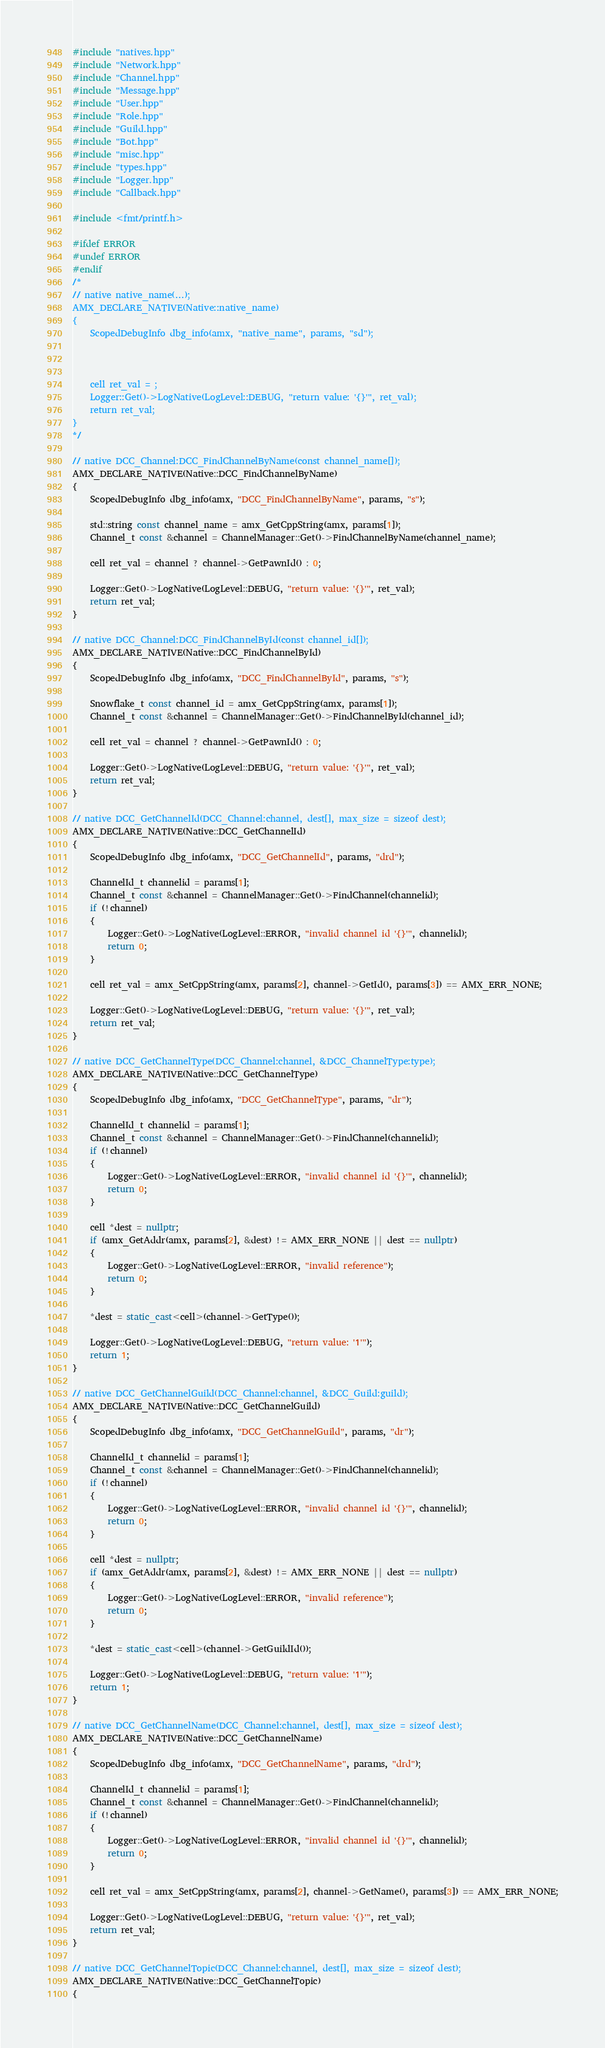<code> <loc_0><loc_0><loc_500><loc_500><_C++_>#include "natives.hpp"
#include "Network.hpp"
#include "Channel.hpp"
#include "Message.hpp"
#include "User.hpp"
#include "Role.hpp"
#include "Guild.hpp"
#include "Bot.hpp"
#include "misc.hpp"
#include "types.hpp"
#include "Logger.hpp"
#include "Callback.hpp"

#include <fmt/printf.h>

#ifdef ERROR
#undef ERROR
#endif
/*
// native native_name(...);
AMX_DECLARE_NATIVE(Native::native_name)
{
	ScopedDebugInfo dbg_info(amx, "native_name", params, "sd");



	cell ret_val = ;
	Logger::Get()->LogNative(LogLevel::DEBUG, "return value: '{}'", ret_val);
	return ret_val;
}
*/

// native DCC_Channel:DCC_FindChannelByName(const channel_name[]);
AMX_DECLARE_NATIVE(Native::DCC_FindChannelByName)
{
	ScopedDebugInfo dbg_info(amx, "DCC_FindChannelByName", params, "s");

	std::string const channel_name = amx_GetCppString(amx, params[1]);
	Channel_t const &channel = ChannelManager::Get()->FindChannelByName(channel_name);

	cell ret_val = channel ? channel->GetPawnId() : 0;

	Logger::Get()->LogNative(LogLevel::DEBUG, "return value: '{}'", ret_val);
	return ret_val;
}

// native DCC_Channel:DCC_FindChannelById(const channel_id[]);
AMX_DECLARE_NATIVE(Native::DCC_FindChannelById)
{
	ScopedDebugInfo dbg_info(amx, "DCC_FindChannelById", params, "s");

	Snowflake_t const channel_id = amx_GetCppString(amx, params[1]);
	Channel_t const &channel = ChannelManager::Get()->FindChannelById(channel_id);

	cell ret_val = channel ? channel->GetPawnId() : 0;

	Logger::Get()->LogNative(LogLevel::DEBUG, "return value: '{}'", ret_val);
	return ret_val;
}

// native DCC_GetChannelId(DCC_Channel:channel, dest[], max_size = sizeof dest);
AMX_DECLARE_NATIVE(Native::DCC_GetChannelId)
{
	ScopedDebugInfo dbg_info(amx, "DCC_GetChannelId", params, "drd");

	ChannelId_t channelid = params[1];
	Channel_t const &channel = ChannelManager::Get()->FindChannel(channelid);
	if (!channel)
	{
		Logger::Get()->LogNative(LogLevel::ERROR, "invalid channel id '{}'", channelid);
		return 0;
	}

	cell ret_val = amx_SetCppString(amx, params[2], channel->GetId(), params[3]) == AMX_ERR_NONE;

	Logger::Get()->LogNative(LogLevel::DEBUG, "return value: '{}'", ret_val);
	return ret_val;
}

// native DCC_GetChannelType(DCC_Channel:channel, &DCC_ChannelType:type);
AMX_DECLARE_NATIVE(Native::DCC_GetChannelType)
{
	ScopedDebugInfo dbg_info(amx, "DCC_GetChannelType", params, "dr");

	ChannelId_t channelid = params[1];
	Channel_t const &channel = ChannelManager::Get()->FindChannel(channelid);
	if (!channel)
	{
		Logger::Get()->LogNative(LogLevel::ERROR, "invalid channel id '{}'", channelid);
		return 0;
	}

	cell *dest = nullptr;
	if (amx_GetAddr(amx, params[2], &dest) != AMX_ERR_NONE || dest == nullptr)
	{
		Logger::Get()->LogNative(LogLevel::ERROR, "invalid reference");
		return 0;
	}

	*dest = static_cast<cell>(channel->GetType());

	Logger::Get()->LogNative(LogLevel::DEBUG, "return value: '1'");
	return 1;
}

// native DCC_GetChannelGuild(DCC_Channel:channel, &DCC_Guild:guild);
AMX_DECLARE_NATIVE(Native::DCC_GetChannelGuild)
{
	ScopedDebugInfo dbg_info(amx, "DCC_GetChannelGuild", params, "dr");

	ChannelId_t channelid = params[1];
	Channel_t const &channel = ChannelManager::Get()->FindChannel(channelid);
	if (!channel)
	{
		Logger::Get()->LogNative(LogLevel::ERROR, "invalid channel id '{}'", channelid);
		return 0;
	}

	cell *dest = nullptr;
	if (amx_GetAddr(amx, params[2], &dest) != AMX_ERR_NONE || dest == nullptr)
	{
		Logger::Get()->LogNative(LogLevel::ERROR, "invalid reference");
		return 0;
	}

	*dest = static_cast<cell>(channel->GetGuildId());

	Logger::Get()->LogNative(LogLevel::DEBUG, "return value: '1'");
	return 1;
}

// native DCC_GetChannelName(DCC_Channel:channel, dest[], max_size = sizeof dest);
AMX_DECLARE_NATIVE(Native::DCC_GetChannelName)
{
	ScopedDebugInfo dbg_info(amx, "DCC_GetChannelName", params, "drd");

	ChannelId_t channelid = params[1];
	Channel_t const &channel = ChannelManager::Get()->FindChannel(channelid);
	if (!channel)
	{
		Logger::Get()->LogNative(LogLevel::ERROR, "invalid channel id '{}'", channelid);
		return 0;
	}

	cell ret_val = amx_SetCppString(amx, params[2], channel->GetName(), params[3]) == AMX_ERR_NONE;

	Logger::Get()->LogNative(LogLevel::DEBUG, "return value: '{}'", ret_val);
	return ret_val;
}

// native DCC_GetChannelTopic(DCC_Channel:channel, dest[], max_size = sizeof dest);
AMX_DECLARE_NATIVE(Native::DCC_GetChannelTopic)
{</code> 